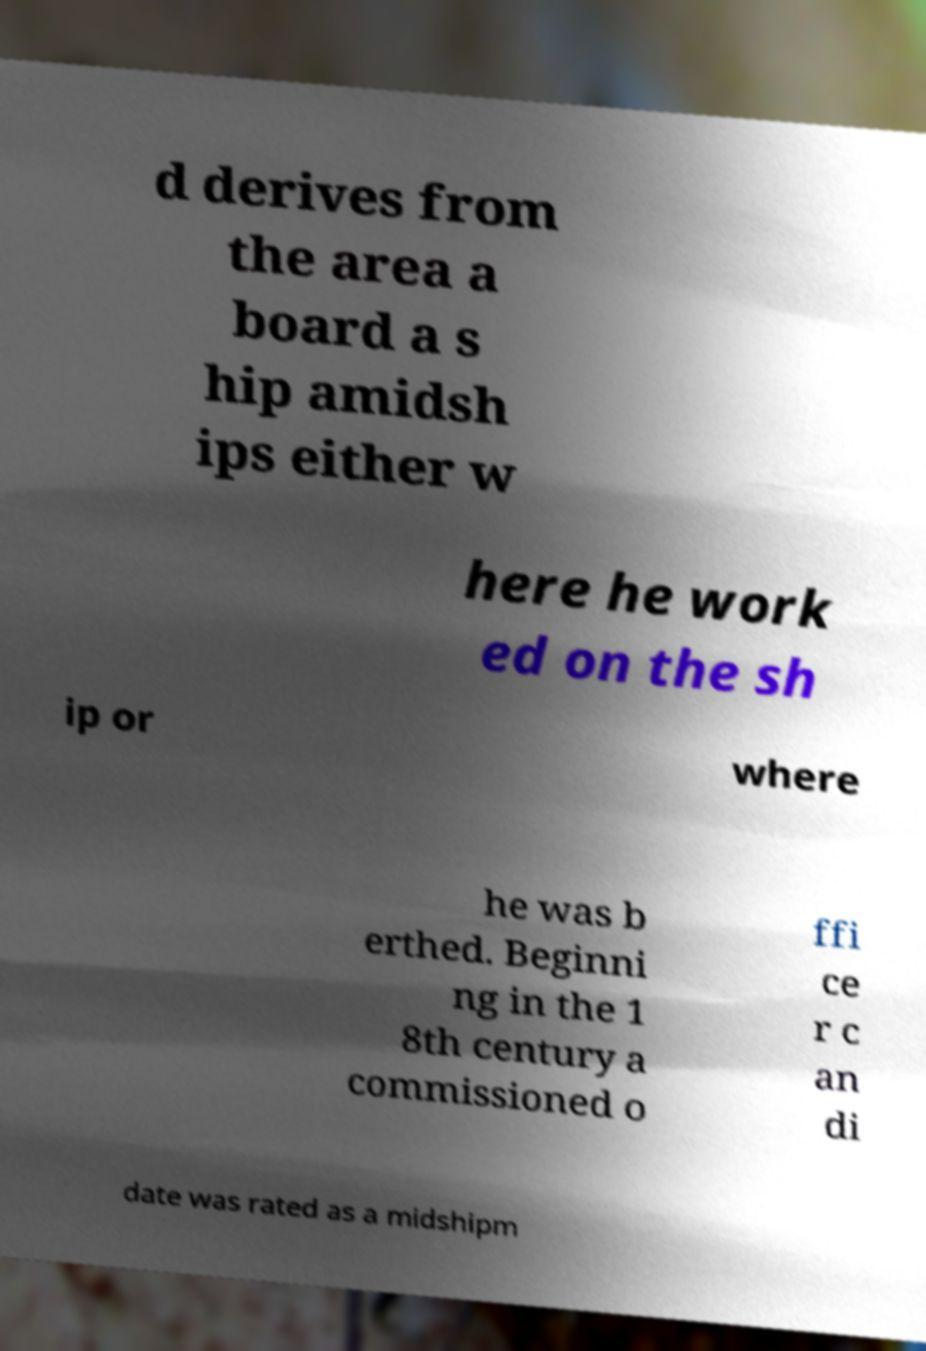Please identify and transcribe the text found in this image. d derives from the area a board a s hip amidsh ips either w here he work ed on the sh ip or where he was b erthed. Beginni ng in the 1 8th century a commissioned o ffi ce r c an di date was rated as a midshipm 